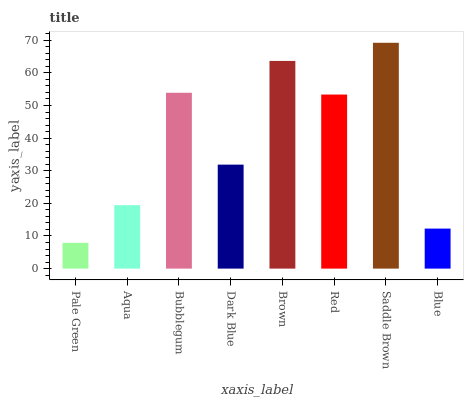Is Pale Green the minimum?
Answer yes or no. Yes. Is Saddle Brown the maximum?
Answer yes or no. Yes. Is Aqua the minimum?
Answer yes or no. No. Is Aqua the maximum?
Answer yes or no. No. Is Aqua greater than Pale Green?
Answer yes or no. Yes. Is Pale Green less than Aqua?
Answer yes or no. Yes. Is Pale Green greater than Aqua?
Answer yes or no. No. Is Aqua less than Pale Green?
Answer yes or no. No. Is Red the high median?
Answer yes or no. Yes. Is Dark Blue the low median?
Answer yes or no. Yes. Is Bubblegum the high median?
Answer yes or no. No. Is Saddle Brown the low median?
Answer yes or no. No. 